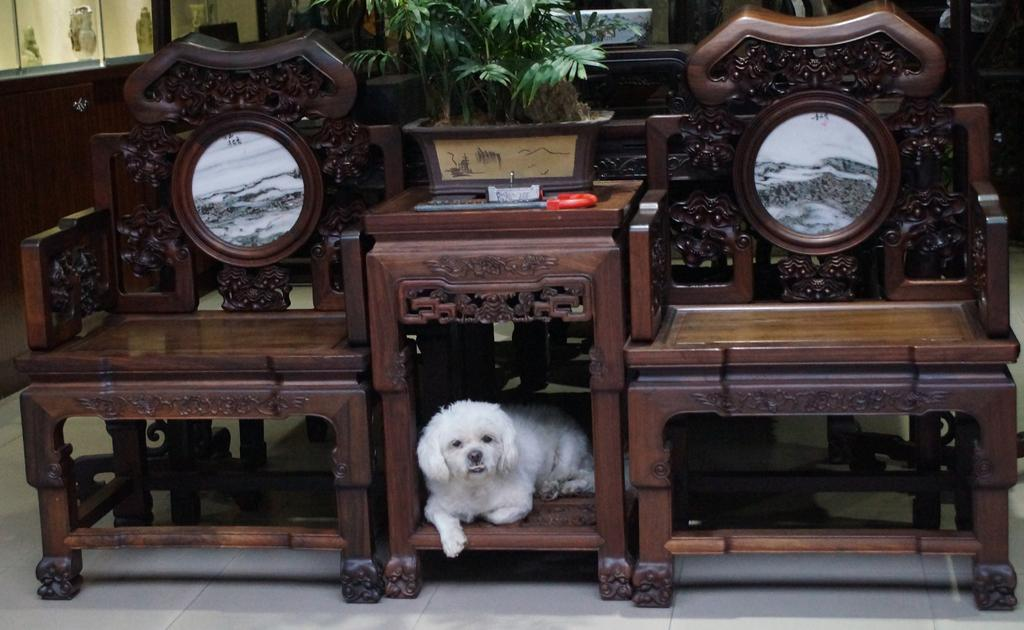What type of furniture is present in the image? There are chairs and a side table in the image. What is placed on the side table? There is a house plant on the side table. What can be seen on the floor beneath the side table? A dog is lying on the floor beneath the side table. What type of patch is visible on the dog's fur in the image? There is no patch visible on the dog's fur in the image; the dog is simply lying on the floor. What type of bear can be seen resting on the chairs in the image? There is no bear present in the image; only chairs, a side table, a house plant, and a dog are visible. 